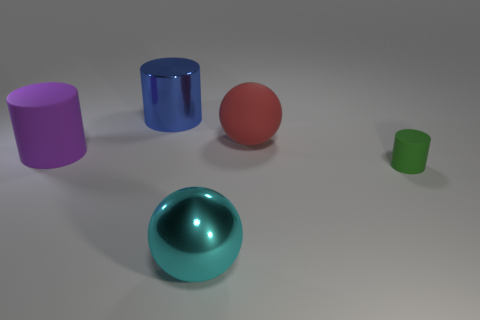There is a thing in front of the tiny cylinder; is there a small matte cylinder on the left side of it?
Keep it short and to the point. No. How many blue shiny objects are in front of the cyan object?
Provide a short and direct response. 0. What number of other objects are the same color as the tiny rubber thing?
Keep it short and to the point. 0. Is the number of large blue metallic things in front of the large blue metallic cylinder less than the number of red objects that are on the left side of the red ball?
Your answer should be compact. No. What number of objects are either metal things that are in front of the small cylinder or small brown rubber balls?
Offer a very short reply. 1. Do the red matte thing and the cylinder behind the large matte sphere have the same size?
Keep it short and to the point. Yes. There is a green object that is the same shape as the blue thing; what size is it?
Give a very brief answer. Small. What number of big red rubber things are on the left side of the large ball in front of the large cylinder that is in front of the red rubber ball?
Make the answer very short. 0. How many cubes are large red rubber things or gray objects?
Make the answer very short. 0. What color is the big cylinder in front of the metal thing behind the large sphere in front of the large red rubber ball?
Offer a terse response. Purple. 